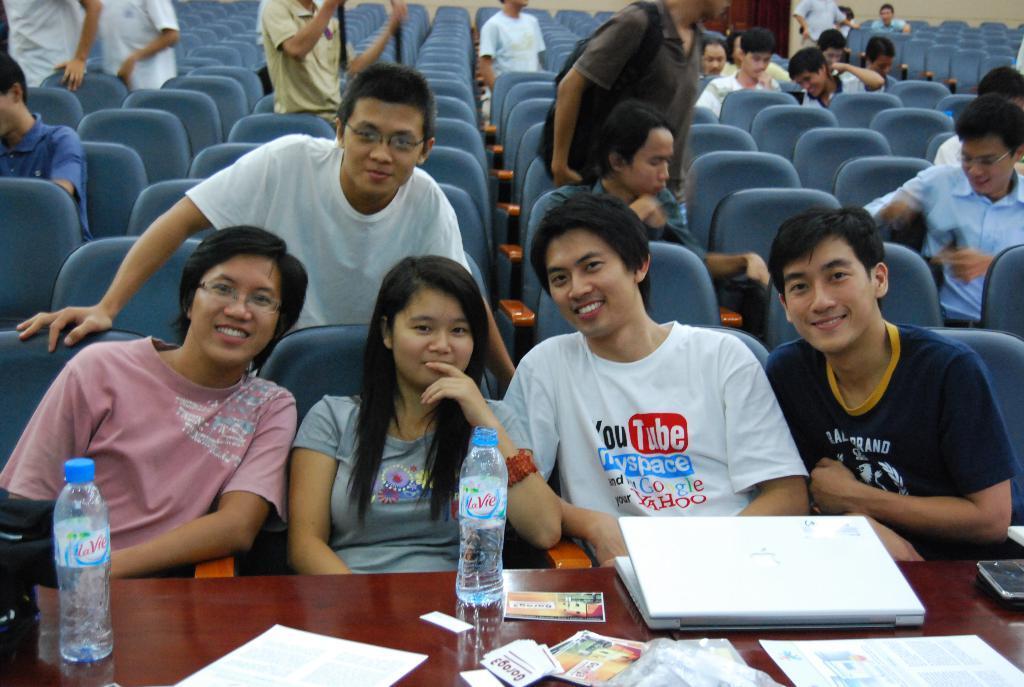How would you summarize this image in a sentence or two? In this image we can see a few people, some of them are sitting on the chairs, there is a table in front of them, on the table there are bottles, papers, cards, a laptop, and a cell phone, also we can see the wall, and a door. 